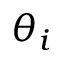Convert formula to latex. <formula><loc_0><loc_0><loc_500><loc_500>\theta _ { i }</formula> 